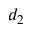<formula> <loc_0><loc_0><loc_500><loc_500>d _ { 2 }</formula> 